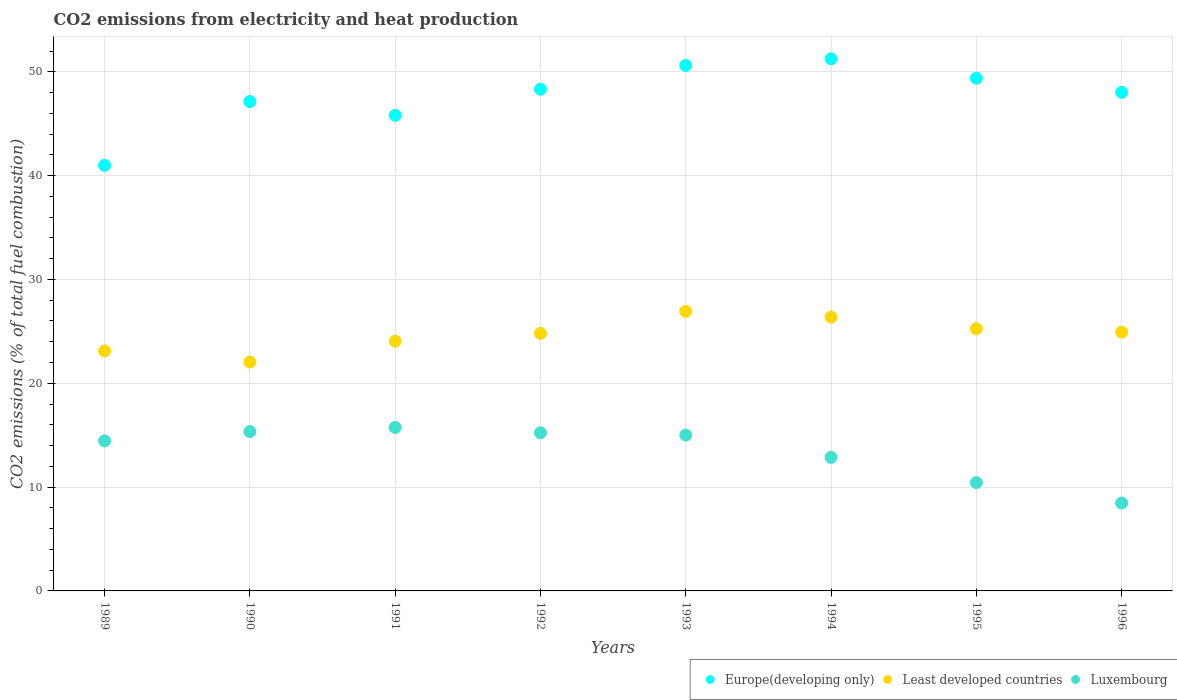What is the amount of CO2 emitted in Least developed countries in 1991?
Your answer should be very brief. 24.05. Across all years, what is the maximum amount of CO2 emitted in Luxembourg?
Provide a short and direct response. 15.75. Across all years, what is the minimum amount of CO2 emitted in Least developed countries?
Keep it short and to the point. 22.05. In which year was the amount of CO2 emitted in Luxembourg maximum?
Offer a terse response. 1991. In which year was the amount of CO2 emitted in Least developed countries minimum?
Give a very brief answer. 1990. What is the total amount of CO2 emitted in Luxembourg in the graph?
Offer a very short reply. 107.55. What is the difference between the amount of CO2 emitted in Europe(developing only) in 1989 and that in 1991?
Your response must be concise. -4.82. What is the difference between the amount of CO2 emitted in Luxembourg in 1989 and the amount of CO2 emitted in Least developed countries in 1995?
Make the answer very short. -10.8. What is the average amount of CO2 emitted in Luxembourg per year?
Your answer should be very brief. 13.44. In the year 1995, what is the difference between the amount of CO2 emitted in Europe(developing only) and amount of CO2 emitted in Least developed countries?
Keep it short and to the point. 24.12. In how many years, is the amount of CO2 emitted in Luxembourg greater than 36 %?
Keep it short and to the point. 0. What is the ratio of the amount of CO2 emitted in Europe(developing only) in 1991 to that in 1992?
Make the answer very short. 0.95. Is the difference between the amount of CO2 emitted in Europe(developing only) in 1991 and 1993 greater than the difference between the amount of CO2 emitted in Least developed countries in 1991 and 1993?
Your response must be concise. No. What is the difference between the highest and the second highest amount of CO2 emitted in Least developed countries?
Offer a terse response. 0.56. What is the difference between the highest and the lowest amount of CO2 emitted in Least developed countries?
Your response must be concise. 4.87. In how many years, is the amount of CO2 emitted in Luxembourg greater than the average amount of CO2 emitted in Luxembourg taken over all years?
Provide a short and direct response. 5. Is the sum of the amount of CO2 emitted in Europe(developing only) in 1992 and 1994 greater than the maximum amount of CO2 emitted in Luxembourg across all years?
Make the answer very short. Yes. Is it the case that in every year, the sum of the amount of CO2 emitted in Europe(developing only) and amount of CO2 emitted in Luxembourg  is greater than the amount of CO2 emitted in Least developed countries?
Your answer should be very brief. Yes. Does the amount of CO2 emitted in Least developed countries monotonically increase over the years?
Ensure brevity in your answer.  No. Is the amount of CO2 emitted in Least developed countries strictly greater than the amount of CO2 emitted in Luxembourg over the years?
Ensure brevity in your answer.  Yes. Is the amount of CO2 emitted in Least developed countries strictly less than the amount of CO2 emitted in Luxembourg over the years?
Make the answer very short. No. How many dotlines are there?
Provide a short and direct response. 3. How many years are there in the graph?
Your answer should be compact. 8. What is the difference between two consecutive major ticks on the Y-axis?
Provide a short and direct response. 10. How many legend labels are there?
Your response must be concise. 3. How are the legend labels stacked?
Keep it short and to the point. Horizontal. What is the title of the graph?
Keep it short and to the point. CO2 emissions from electricity and heat production. Does "Virgin Islands" appear as one of the legend labels in the graph?
Give a very brief answer. No. What is the label or title of the Y-axis?
Provide a short and direct response. CO2 emissions (% of total fuel combustion). What is the CO2 emissions (% of total fuel combustion) of Europe(developing only) in 1989?
Provide a short and direct response. 40.99. What is the CO2 emissions (% of total fuel combustion) of Least developed countries in 1989?
Your response must be concise. 23.12. What is the CO2 emissions (% of total fuel combustion) of Luxembourg in 1989?
Keep it short and to the point. 14.45. What is the CO2 emissions (% of total fuel combustion) of Europe(developing only) in 1990?
Your response must be concise. 47.13. What is the CO2 emissions (% of total fuel combustion) in Least developed countries in 1990?
Provide a short and direct response. 22.05. What is the CO2 emissions (% of total fuel combustion) of Luxembourg in 1990?
Provide a short and direct response. 15.35. What is the CO2 emissions (% of total fuel combustion) in Europe(developing only) in 1991?
Make the answer very short. 45.8. What is the CO2 emissions (% of total fuel combustion) of Least developed countries in 1991?
Offer a very short reply. 24.05. What is the CO2 emissions (% of total fuel combustion) in Luxembourg in 1991?
Offer a very short reply. 15.75. What is the CO2 emissions (% of total fuel combustion) in Europe(developing only) in 1992?
Offer a terse response. 48.32. What is the CO2 emissions (% of total fuel combustion) in Least developed countries in 1992?
Your answer should be compact. 24.81. What is the CO2 emissions (% of total fuel combustion) in Luxembourg in 1992?
Your answer should be compact. 15.23. What is the CO2 emissions (% of total fuel combustion) of Europe(developing only) in 1993?
Provide a short and direct response. 50.61. What is the CO2 emissions (% of total fuel combustion) of Least developed countries in 1993?
Ensure brevity in your answer.  26.92. What is the CO2 emissions (% of total fuel combustion) of Luxembourg in 1993?
Keep it short and to the point. 15.01. What is the CO2 emissions (% of total fuel combustion) of Europe(developing only) in 1994?
Offer a very short reply. 51.25. What is the CO2 emissions (% of total fuel combustion) of Least developed countries in 1994?
Your answer should be very brief. 26.37. What is the CO2 emissions (% of total fuel combustion) in Luxembourg in 1994?
Offer a terse response. 12.86. What is the CO2 emissions (% of total fuel combustion) of Europe(developing only) in 1995?
Make the answer very short. 49.38. What is the CO2 emissions (% of total fuel combustion) in Least developed countries in 1995?
Ensure brevity in your answer.  25.25. What is the CO2 emissions (% of total fuel combustion) in Luxembourg in 1995?
Your answer should be very brief. 10.43. What is the CO2 emissions (% of total fuel combustion) of Europe(developing only) in 1996?
Offer a very short reply. 48.02. What is the CO2 emissions (% of total fuel combustion) in Least developed countries in 1996?
Your answer should be very brief. 24.92. What is the CO2 emissions (% of total fuel combustion) in Luxembourg in 1996?
Offer a very short reply. 8.47. Across all years, what is the maximum CO2 emissions (% of total fuel combustion) of Europe(developing only)?
Ensure brevity in your answer.  51.25. Across all years, what is the maximum CO2 emissions (% of total fuel combustion) in Least developed countries?
Your response must be concise. 26.92. Across all years, what is the maximum CO2 emissions (% of total fuel combustion) in Luxembourg?
Your answer should be very brief. 15.75. Across all years, what is the minimum CO2 emissions (% of total fuel combustion) of Europe(developing only)?
Provide a succinct answer. 40.99. Across all years, what is the minimum CO2 emissions (% of total fuel combustion) in Least developed countries?
Your answer should be very brief. 22.05. Across all years, what is the minimum CO2 emissions (% of total fuel combustion) in Luxembourg?
Give a very brief answer. 8.47. What is the total CO2 emissions (% of total fuel combustion) in Europe(developing only) in the graph?
Provide a succinct answer. 381.5. What is the total CO2 emissions (% of total fuel combustion) in Least developed countries in the graph?
Keep it short and to the point. 197.49. What is the total CO2 emissions (% of total fuel combustion) in Luxembourg in the graph?
Provide a succinct answer. 107.55. What is the difference between the CO2 emissions (% of total fuel combustion) of Europe(developing only) in 1989 and that in 1990?
Make the answer very short. -6.14. What is the difference between the CO2 emissions (% of total fuel combustion) in Least developed countries in 1989 and that in 1990?
Make the answer very short. 1.07. What is the difference between the CO2 emissions (% of total fuel combustion) in Luxembourg in 1989 and that in 1990?
Provide a short and direct response. -0.89. What is the difference between the CO2 emissions (% of total fuel combustion) in Europe(developing only) in 1989 and that in 1991?
Offer a terse response. -4.82. What is the difference between the CO2 emissions (% of total fuel combustion) of Least developed countries in 1989 and that in 1991?
Give a very brief answer. -0.93. What is the difference between the CO2 emissions (% of total fuel combustion) of Luxembourg in 1989 and that in 1991?
Your answer should be compact. -1.29. What is the difference between the CO2 emissions (% of total fuel combustion) of Europe(developing only) in 1989 and that in 1992?
Your answer should be very brief. -7.33. What is the difference between the CO2 emissions (% of total fuel combustion) of Least developed countries in 1989 and that in 1992?
Make the answer very short. -1.69. What is the difference between the CO2 emissions (% of total fuel combustion) of Luxembourg in 1989 and that in 1992?
Your answer should be very brief. -0.78. What is the difference between the CO2 emissions (% of total fuel combustion) in Europe(developing only) in 1989 and that in 1993?
Offer a terse response. -9.62. What is the difference between the CO2 emissions (% of total fuel combustion) in Least developed countries in 1989 and that in 1993?
Offer a very short reply. -3.81. What is the difference between the CO2 emissions (% of total fuel combustion) in Luxembourg in 1989 and that in 1993?
Provide a succinct answer. -0.56. What is the difference between the CO2 emissions (% of total fuel combustion) in Europe(developing only) in 1989 and that in 1994?
Provide a succinct answer. -10.26. What is the difference between the CO2 emissions (% of total fuel combustion) of Least developed countries in 1989 and that in 1994?
Your answer should be very brief. -3.25. What is the difference between the CO2 emissions (% of total fuel combustion) of Luxembourg in 1989 and that in 1994?
Give a very brief answer. 1.59. What is the difference between the CO2 emissions (% of total fuel combustion) in Europe(developing only) in 1989 and that in 1995?
Your answer should be compact. -8.39. What is the difference between the CO2 emissions (% of total fuel combustion) of Least developed countries in 1989 and that in 1995?
Ensure brevity in your answer.  -2.14. What is the difference between the CO2 emissions (% of total fuel combustion) of Luxembourg in 1989 and that in 1995?
Offer a terse response. 4.02. What is the difference between the CO2 emissions (% of total fuel combustion) of Europe(developing only) in 1989 and that in 1996?
Keep it short and to the point. -7.03. What is the difference between the CO2 emissions (% of total fuel combustion) in Least developed countries in 1989 and that in 1996?
Keep it short and to the point. -1.81. What is the difference between the CO2 emissions (% of total fuel combustion) of Luxembourg in 1989 and that in 1996?
Your response must be concise. 5.99. What is the difference between the CO2 emissions (% of total fuel combustion) of Europe(developing only) in 1990 and that in 1991?
Make the answer very short. 1.32. What is the difference between the CO2 emissions (% of total fuel combustion) in Least developed countries in 1990 and that in 1991?
Your answer should be compact. -2. What is the difference between the CO2 emissions (% of total fuel combustion) in Luxembourg in 1990 and that in 1991?
Offer a very short reply. -0.4. What is the difference between the CO2 emissions (% of total fuel combustion) of Europe(developing only) in 1990 and that in 1992?
Your response must be concise. -1.19. What is the difference between the CO2 emissions (% of total fuel combustion) of Least developed countries in 1990 and that in 1992?
Your answer should be very brief. -2.76. What is the difference between the CO2 emissions (% of total fuel combustion) in Luxembourg in 1990 and that in 1992?
Give a very brief answer. 0.12. What is the difference between the CO2 emissions (% of total fuel combustion) in Europe(developing only) in 1990 and that in 1993?
Your response must be concise. -3.48. What is the difference between the CO2 emissions (% of total fuel combustion) of Least developed countries in 1990 and that in 1993?
Ensure brevity in your answer.  -4.87. What is the difference between the CO2 emissions (% of total fuel combustion) of Luxembourg in 1990 and that in 1993?
Your answer should be compact. 0.34. What is the difference between the CO2 emissions (% of total fuel combustion) in Europe(developing only) in 1990 and that in 1994?
Ensure brevity in your answer.  -4.12. What is the difference between the CO2 emissions (% of total fuel combustion) of Least developed countries in 1990 and that in 1994?
Give a very brief answer. -4.32. What is the difference between the CO2 emissions (% of total fuel combustion) of Luxembourg in 1990 and that in 1994?
Ensure brevity in your answer.  2.49. What is the difference between the CO2 emissions (% of total fuel combustion) in Europe(developing only) in 1990 and that in 1995?
Ensure brevity in your answer.  -2.25. What is the difference between the CO2 emissions (% of total fuel combustion) of Least developed countries in 1990 and that in 1995?
Make the answer very short. -3.2. What is the difference between the CO2 emissions (% of total fuel combustion) of Luxembourg in 1990 and that in 1995?
Your answer should be very brief. 4.91. What is the difference between the CO2 emissions (% of total fuel combustion) of Europe(developing only) in 1990 and that in 1996?
Your response must be concise. -0.89. What is the difference between the CO2 emissions (% of total fuel combustion) of Least developed countries in 1990 and that in 1996?
Offer a very short reply. -2.87. What is the difference between the CO2 emissions (% of total fuel combustion) of Luxembourg in 1990 and that in 1996?
Provide a succinct answer. 6.88. What is the difference between the CO2 emissions (% of total fuel combustion) in Europe(developing only) in 1991 and that in 1992?
Give a very brief answer. -2.52. What is the difference between the CO2 emissions (% of total fuel combustion) of Least developed countries in 1991 and that in 1992?
Make the answer very short. -0.76. What is the difference between the CO2 emissions (% of total fuel combustion) in Luxembourg in 1991 and that in 1992?
Your answer should be compact. 0.51. What is the difference between the CO2 emissions (% of total fuel combustion) of Europe(developing only) in 1991 and that in 1993?
Provide a succinct answer. -4.81. What is the difference between the CO2 emissions (% of total fuel combustion) of Least developed countries in 1991 and that in 1993?
Give a very brief answer. -2.87. What is the difference between the CO2 emissions (% of total fuel combustion) in Luxembourg in 1991 and that in 1993?
Ensure brevity in your answer.  0.74. What is the difference between the CO2 emissions (% of total fuel combustion) of Europe(developing only) in 1991 and that in 1994?
Give a very brief answer. -5.45. What is the difference between the CO2 emissions (% of total fuel combustion) of Least developed countries in 1991 and that in 1994?
Your answer should be very brief. -2.32. What is the difference between the CO2 emissions (% of total fuel combustion) of Luxembourg in 1991 and that in 1994?
Your answer should be compact. 2.88. What is the difference between the CO2 emissions (% of total fuel combustion) in Europe(developing only) in 1991 and that in 1995?
Your response must be concise. -3.57. What is the difference between the CO2 emissions (% of total fuel combustion) in Least developed countries in 1991 and that in 1995?
Your answer should be very brief. -1.2. What is the difference between the CO2 emissions (% of total fuel combustion) in Luxembourg in 1991 and that in 1995?
Offer a very short reply. 5.31. What is the difference between the CO2 emissions (% of total fuel combustion) of Europe(developing only) in 1991 and that in 1996?
Your answer should be compact. -2.21. What is the difference between the CO2 emissions (% of total fuel combustion) of Least developed countries in 1991 and that in 1996?
Give a very brief answer. -0.87. What is the difference between the CO2 emissions (% of total fuel combustion) in Luxembourg in 1991 and that in 1996?
Give a very brief answer. 7.28. What is the difference between the CO2 emissions (% of total fuel combustion) of Europe(developing only) in 1992 and that in 1993?
Give a very brief answer. -2.29. What is the difference between the CO2 emissions (% of total fuel combustion) of Least developed countries in 1992 and that in 1993?
Provide a short and direct response. -2.12. What is the difference between the CO2 emissions (% of total fuel combustion) of Luxembourg in 1992 and that in 1993?
Give a very brief answer. 0.22. What is the difference between the CO2 emissions (% of total fuel combustion) of Europe(developing only) in 1992 and that in 1994?
Your answer should be very brief. -2.93. What is the difference between the CO2 emissions (% of total fuel combustion) of Least developed countries in 1992 and that in 1994?
Provide a succinct answer. -1.56. What is the difference between the CO2 emissions (% of total fuel combustion) of Luxembourg in 1992 and that in 1994?
Ensure brevity in your answer.  2.37. What is the difference between the CO2 emissions (% of total fuel combustion) of Europe(developing only) in 1992 and that in 1995?
Provide a succinct answer. -1.06. What is the difference between the CO2 emissions (% of total fuel combustion) of Least developed countries in 1992 and that in 1995?
Offer a very short reply. -0.45. What is the difference between the CO2 emissions (% of total fuel combustion) of Luxembourg in 1992 and that in 1995?
Provide a succinct answer. 4.8. What is the difference between the CO2 emissions (% of total fuel combustion) of Europe(developing only) in 1992 and that in 1996?
Provide a short and direct response. 0.3. What is the difference between the CO2 emissions (% of total fuel combustion) of Least developed countries in 1992 and that in 1996?
Offer a terse response. -0.12. What is the difference between the CO2 emissions (% of total fuel combustion) of Luxembourg in 1992 and that in 1996?
Offer a very short reply. 6.77. What is the difference between the CO2 emissions (% of total fuel combustion) of Europe(developing only) in 1993 and that in 1994?
Keep it short and to the point. -0.64. What is the difference between the CO2 emissions (% of total fuel combustion) of Least developed countries in 1993 and that in 1994?
Offer a terse response. 0.56. What is the difference between the CO2 emissions (% of total fuel combustion) of Luxembourg in 1993 and that in 1994?
Keep it short and to the point. 2.15. What is the difference between the CO2 emissions (% of total fuel combustion) of Europe(developing only) in 1993 and that in 1995?
Your answer should be compact. 1.23. What is the difference between the CO2 emissions (% of total fuel combustion) of Least developed countries in 1993 and that in 1995?
Ensure brevity in your answer.  1.67. What is the difference between the CO2 emissions (% of total fuel combustion) of Luxembourg in 1993 and that in 1995?
Your answer should be compact. 4.57. What is the difference between the CO2 emissions (% of total fuel combustion) in Europe(developing only) in 1993 and that in 1996?
Provide a succinct answer. 2.59. What is the difference between the CO2 emissions (% of total fuel combustion) of Least developed countries in 1993 and that in 1996?
Make the answer very short. 2. What is the difference between the CO2 emissions (% of total fuel combustion) in Luxembourg in 1993 and that in 1996?
Give a very brief answer. 6.54. What is the difference between the CO2 emissions (% of total fuel combustion) of Europe(developing only) in 1994 and that in 1995?
Give a very brief answer. 1.87. What is the difference between the CO2 emissions (% of total fuel combustion) in Least developed countries in 1994 and that in 1995?
Provide a succinct answer. 1.12. What is the difference between the CO2 emissions (% of total fuel combustion) in Luxembourg in 1994 and that in 1995?
Your answer should be very brief. 2.43. What is the difference between the CO2 emissions (% of total fuel combustion) of Europe(developing only) in 1994 and that in 1996?
Provide a succinct answer. 3.23. What is the difference between the CO2 emissions (% of total fuel combustion) of Least developed countries in 1994 and that in 1996?
Offer a very short reply. 1.45. What is the difference between the CO2 emissions (% of total fuel combustion) of Luxembourg in 1994 and that in 1996?
Keep it short and to the point. 4.4. What is the difference between the CO2 emissions (% of total fuel combustion) in Europe(developing only) in 1995 and that in 1996?
Provide a short and direct response. 1.36. What is the difference between the CO2 emissions (% of total fuel combustion) of Least developed countries in 1995 and that in 1996?
Keep it short and to the point. 0.33. What is the difference between the CO2 emissions (% of total fuel combustion) of Luxembourg in 1995 and that in 1996?
Ensure brevity in your answer.  1.97. What is the difference between the CO2 emissions (% of total fuel combustion) in Europe(developing only) in 1989 and the CO2 emissions (% of total fuel combustion) in Least developed countries in 1990?
Give a very brief answer. 18.94. What is the difference between the CO2 emissions (% of total fuel combustion) in Europe(developing only) in 1989 and the CO2 emissions (% of total fuel combustion) in Luxembourg in 1990?
Provide a short and direct response. 25.64. What is the difference between the CO2 emissions (% of total fuel combustion) of Least developed countries in 1989 and the CO2 emissions (% of total fuel combustion) of Luxembourg in 1990?
Offer a terse response. 7.77. What is the difference between the CO2 emissions (% of total fuel combustion) of Europe(developing only) in 1989 and the CO2 emissions (% of total fuel combustion) of Least developed countries in 1991?
Provide a succinct answer. 16.94. What is the difference between the CO2 emissions (% of total fuel combustion) in Europe(developing only) in 1989 and the CO2 emissions (% of total fuel combustion) in Luxembourg in 1991?
Keep it short and to the point. 25.24. What is the difference between the CO2 emissions (% of total fuel combustion) of Least developed countries in 1989 and the CO2 emissions (% of total fuel combustion) of Luxembourg in 1991?
Provide a succinct answer. 7.37. What is the difference between the CO2 emissions (% of total fuel combustion) in Europe(developing only) in 1989 and the CO2 emissions (% of total fuel combustion) in Least developed countries in 1992?
Offer a very short reply. 16.18. What is the difference between the CO2 emissions (% of total fuel combustion) of Europe(developing only) in 1989 and the CO2 emissions (% of total fuel combustion) of Luxembourg in 1992?
Offer a very short reply. 25.76. What is the difference between the CO2 emissions (% of total fuel combustion) in Least developed countries in 1989 and the CO2 emissions (% of total fuel combustion) in Luxembourg in 1992?
Offer a very short reply. 7.88. What is the difference between the CO2 emissions (% of total fuel combustion) in Europe(developing only) in 1989 and the CO2 emissions (% of total fuel combustion) in Least developed countries in 1993?
Your answer should be compact. 14.06. What is the difference between the CO2 emissions (% of total fuel combustion) of Europe(developing only) in 1989 and the CO2 emissions (% of total fuel combustion) of Luxembourg in 1993?
Give a very brief answer. 25.98. What is the difference between the CO2 emissions (% of total fuel combustion) of Least developed countries in 1989 and the CO2 emissions (% of total fuel combustion) of Luxembourg in 1993?
Ensure brevity in your answer.  8.11. What is the difference between the CO2 emissions (% of total fuel combustion) in Europe(developing only) in 1989 and the CO2 emissions (% of total fuel combustion) in Least developed countries in 1994?
Your answer should be compact. 14.62. What is the difference between the CO2 emissions (% of total fuel combustion) in Europe(developing only) in 1989 and the CO2 emissions (% of total fuel combustion) in Luxembourg in 1994?
Make the answer very short. 28.13. What is the difference between the CO2 emissions (% of total fuel combustion) of Least developed countries in 1989 and the CO2 emissions (% of total fuel combustion) of Luxembourg in 1994?
Your response must be concise. 10.25. What is the difference between the CO2 emissions (% of total fuel combustion) in Europe(developing only) in 1989 and the CO2 emissions (% of total fuel combustion) in Least developed countries in 1995?
Your response must be concise. 15.73. What is the difference between the CO2 emissions (% of total fuel combustion) in Europe(developing only) in 1989 and the CO2 emissions (% of total fuel combustion) in Luxembourg in 1995?
Provide a succinct answer. 30.55. What is the difference between the CO2 emissions (% of total fuel combustion) of Least developed countries in 1989 and the CO2 emissions (% of total fuel combustion) of Luxembourg in 1995?
Your response must be concise. 12.68. What is the difference between the CO2 emissions (% of total fuel combustion) in Europe(developing only) in 1989 and the CO2 emissions (% of total fuel combustion) in Least developed countries in 1996?
Give a very brief answer. 16.06. What is the difference between the CO2 emissions (% of total fuel combustion) in Europe(developing only) in 1989 and the CO2 emissions (% of total fuel combustion) in Luxembourg in 1996?
Your response must be concise. 32.52. What is the difference between the CO2 emissions (% of total fuel combustion) in Least developed countries in 1989 and the CO2 emissions (% of total fuel combustion) in Luxembourg in 1996?
Offer a terse response. 14.65. What is the difference between the CO2 emissions (% of total fuel combustion) of Europe(developing only) in 1990 and the CO2 emissions (% of total fuel combustion) of Least developed countries in 1991?
Your answer should be compact. 23.08. What is the difference between the CO2 emissions (% of total fuel combustion) of Europe(developing only) in 1990 and the CO2 emissions (% of total fuel combustion) of Luxembourg in 1991?
Keep it short and to the point. 31.38. What is the difference between the CO2 emissions (% of total fuel combustion) in Least developed countries in 1990 and the CO2 emissions (% of total fuel combustion) in Luxembourg in 1991?
Your answer should be very brief. 6.3. What is the difference between the CO2 emissions (% of total fuel combustion) of Europe(developing only) in 1990 and the CO2 emissions (% of total fuel combustion) of Least developed countries in 1992?
Offer a very short reply. 22.32. What is the difference between the CO2 emissions (% of total fuel combustion) in Europe(developing only) in 1990 and the CO2 emissions (% of total fuel combustion) in Luxembourg in 1992?
Make the answer very short. 31.9. What is the difference between the CO2 emissions (% of total fuel combustion) in Least developed countries in 1990 and the CO2 emissions (% of total fuel combustion) in Luxembourg in 1992?
Make the answer very short. 6.82. What is the difference between the CO2 emissions (% of total fuel combustion) of Europe(developing only) in 1990 and the CO2 emissions (% of total fuel combustion) of Least developed countries in 1993?
Ensure brevity in your answer.  20.2. What is the difference between the CO2 emissions (% of total fuel combustion) in Europe(developing only) in 1990 and the CO2 emissions (% of total fuel combustion) in Luxembourg in 1993?
Your answer should be compact. 32.12. What is the difference between the CO2 emissions (% of total fuel combustion) of Least developed countries in 1990 and the CO2 emissions (% of total fuel combustion) of Luxembourg in 1993?
Your answer should be very brief. 7.04. What is the difference between the CO2 emissions (% of total fuel combustion) in Europe(developing only) in 1990 and the CO2 emissions (% of total fuel combustion) in Least developed countries in 1994?
Ensure brevity in your answer.  20.76. What is the difference between the CO2 emissions (% of total fuel combustion) in Europe(developing only) in 1990 and the CO2 emissions (% of total fuel combustion) in Luxembourg in 1994?
Your answer should be very brief. 34.27. What is the difference between the CO2 emissions (% of total fuel combustion) in Least developed countries in 1990 and the CO2 emissions (% of total fuel combustion) in Luxembourg in 1994?
Ensure brevity in your answer.  9.19. What is the difference between the CO2 emissions (% of total fuel combustion) in Europe(developing only) in 1990 and the CO2 emissions (% of total fuel combustion) in Least developed countries in 1995?
Your answer should be compact. 21.88. What is the difference between the CO2 emissions (% of total fuel combustion) in Europe(developing only) in 1990 and the CO2 emissions (% of total fuel combustion) in Luxembourg in 1995?
Make the answer very short. 36.69. What is the difference between the CO2 emissions (% of total fuel combustion) of Least developed countries in 1990 and the CO2 emissions (% of total fuel combustion) of Luxembourg in 1995?
Make the answer very short. 11.61. What is the difference between the CO2 emissions (% of total fuel combustion) of Europe(developing only) in 1990 and the CO2 emissions (% of total fuel combustion) of Least developed countries in 1996?
Provide a succinct answer. 22.2. What is the difference between the CO2 emissions (% of total fuel combustion) in Europe(developing only) in 1990 and the CO2 emissions (% of total fuel combustion) in Luxembourg in 1996?
Your response must be concise. 38.66. What is the difference between the CO2 emissions (% of total fuel combustion) in Least developed countries in 1990 and the CO2 emissions (% of total fuel combustion) in Luxembourg in 1996?
Keep it short and to the point. 13.58. What is the difference between the CO2 emissions (% of total fuel combustion) of Europe(developing only) in 1991 and the CO2 emissions (% of total fuel combustion) of Least developed countries in 1992?
Keep it short and to the point. 21. What is the difference between the CO2 emissions (% of total fuel combustion) in Europe(developing only) in 1991 and the CO2 emissions (% of total fuel combustion) in Luxembourg in 1992?
Keep it short and to the point. 30.57. What is the difference between the CO2 emissions (% of total fuel combustion) of Least developed countries in 1991 and the CO2 emissions (% of total fuel combustion) of Luxembourg in 1992?
Keep it short and to the point. 8.82. What is the difference between the CO2 emissions (% of total fuel combustion) in Europe(developing only) in 1991 and the CO2 emissions (% of total fuel combustion) in Least developed countries in 1993?
Make the answer very short. 18.88. What is the difference between the CO2 emissions (% of total fuel combustion) in Europe(developing only) in 1991 and the CO2 emissions (% of total fuel combustion) in Luxembourg in 1993?
Offer a terse response. 30.8. What is the difference between the CO2 emissions (% of total fuel combustion) of Least developed countries in 1991 and the CO2 emissions (% of total fuel combustion) of Luxembourg in 1993?
Give a very brief answer. 9.04. What is the difference between the CO2 emissions (% of total fuel combustion) of Europe(developing only) in 1991 and the CO2 emissions (% of total fuel combustion) of Least developed countries in 1994?
Keep it short and to the point. 19.44. What is the difference between the CO2 emissions (% of total fuel combustion) in Europe(developing only) in 1991 and the CO2 emissions (% of total fuel combustion) in Luxembourg in 1994?
Your answer should be compact. 32.94. What is the difference between the CO2 emissions (% of total fuel combustion) in Least developed countries in 1991 and the CO2 emissions (% of total fuel combustion) in Luxembourg in 1994?
Offer a terse response. 11.19. What is the difference between the CO2 emissions (% of total fuel combustion) of Europe(developing only) in 1991 and the CO2 emissions (% of total fuel combustion) of Least developed countries in 1995?
Offer a very short reply. 20.55. What is the difference between the CO2 emissions (% of total fuel combustion) of Europe(developing only) in 1991 and the CO2 emissions (% of total fuel combustion) of Luxembourg in 1995?
Your answer should be compact. 35.37. What is the difference between the CO2 emissions (% of total fuel combustion) of Least developed countries in 1991 and the CO2 emissions (% of total fuel combustion) of Luxembourg in 1995?
Keep it short and to the point. 13.61. What is the difference between the CO2 emissions (% of total fuel combustion) in Europe(developing only) in 1991 and the CO2 emissions (% of total fuel combustion) in Least developed countries in 1996?
Keep it short and to the point. 20.88. What is the difference between the CO2 emissions (% of total fuel combustion) in Europe(developing only) in 1991 and the CO2 emissions (% of total fuel combustion) in Luxembourg in 1996?
Provide a succinct answer. 37.34. What is the difference between the CO2 emissions (% of total fuel combustion) in Least developed countries in 1991 and the CO2 emissions (% of total fuel combustion) in Luxembourg in 1996?
Your answer should be compact. 15.58. What is the difference between the CO2 emissions (% of total fuel combustion) in Europe(developing only) in 1992 and the CO2 emissions (% of total fuel combustion) in Least developed countries in 1993?
Provide a succinct answer. 21.4. What is the difference between the CO2 emissions (% of total fuel combustion) of Europe(developing only) in 1992 and the CO2 emissions (% of total fuel combustion) of Luxembourg in 1993?
Provide a short and direct response. 33.31. What is the difference between the CO2 emissions (% of total fuel combustion) of Least developed countries in 1992 and the CO2 emissions (% of total fuel combustion) of Luxembourg in 1993?
Your answer should be very brief. 9.8. What is the difference between the CO2 emissions (% of total fuel combustion) of Europe(developing only) in 1992 and the CO2 emissions (% of total fuel combustion) of Least developed countries in 1994?
Provide a short and direct response. 21.95. What is the difference between the CO2 emissions (% of total fuel combustion) in Europe(developing only) in 1992 and the CO2 emissions (% of total fuel combustion) in Luxembourg in 1994?
Your response must be concise. 35.46. What is the difference between the CO2 emissions (% of total fuel combustion) of Least developed countries in 1992 and the CO2 emissions (% of total fuel combustion) of Luxembourg in 1994?
Make the answer very short. 11.94. What is the difference between the CO2 emissions (% of total fuel combustion) in Europe(developing only) in 1992 and the CO2 emissions (% of total fuel combustion) in Least developed countries in 1995?
Offer a terse response. 23.07. What is the difference between the CO2 emissions (% of total fuel combustion) of Europe(developing only) in 1992 and the CO2 emissions (% of total fuel combustion) of Luxembourg in 1995?
Ensure brevity in your answer.  37.89. What is the difference between the CO2 emissions (% of total fuel combustion) of Least developed countries in 1992 and the CO2 emissions (% of total fuel combustion) of Luxembourg in 1995?
Give a very brief answer. 14.37. What is the difference between the CO2 emissions (% of total fuel combustion) of Europe(developing only) in 1992 and the CO2 emissions (% of total fuel combustion) of Least developed countries in 1996?
Your response must be concise. 23.4. What is the difference between the CO2 emissions (% of total fuel combustion) of Europe(developing only) in 1992 and the CO2 emissions (% of total fuel combustion) of Luxembourg in 1996?
Make the answer very short. 39.85. What is the difference between the CO2 emissions (% of total fuel combustion) of Least developed countries in 1992 and the CO2 emissions (% of total fuel combustion) of Luxembourg in 1996?
Offer a very short reply. 16.34. What is the difference between the CO2 emissions (% of total fuel combustion) of Europe(developing only) in 1993 and the CO2 emissions (% of total fuel combustion) of Least developed countries in 1994?
Your answer should be compact. 24.24. What is the difference between the CO2 emissions (% of total fuel combustion) in Europe(developing only) in 1993 and the CO2 emissions (% of total fuel combustion) in Luxembourg in 1994?
Give a very brief answer. 37.75. What is the difference between the CO2 emissions (% of total fuel combustion) in Least developed countries in 1993 and the CO2 emissions (% of total fuel combustion) in Luxembourg in 1994?
Make the answer very short. 14.06. What is the difference between the CO2 emissions (% of total fuel combustion) in Europe(developing only) in 1993 and the CO2 emissions (% of total fuel combustion) in Least developed countries in 1995?
Provide a short and direct response. 25.36. What is the difference between the CO2 emissions (% of total fuel combustion) in Europe(developing only) in 1993 and the CO2 emissions (% of total fuel combustion) in Luxembourg in 1995?
Your response must be concise. 40.18. What is the difference between the CO2 emissions (% of total fuel combustion) in Least developed countries in 1993 and the CO2 emissions (% of total fuel combustion) in Luxembourg in 1995?
Keep it short and to the point. 16.49. What is the difference between the CO2 emissions (% of total fuel combustion) of Europe(developing only) in 1993 and the CO2 emissions (% of total fuel combustion) of Least developed countries in 1996?
Provide a succinct answer. 25.69. What is the difference between the CO2 emissions (% of total fuel combustion) in Europe(developing only) in 1993 and the CO2 emissions (% of total fuel combustion) in Luxembourg in 1996?
Make the answer very short. 42.14. What is the difference between the CO2 emissions (% of total fuel combustion) in Least developed countries in 1993 and the CO2 emissions (% of total fuel combustion) in Luxembourg in 1996?
Provide a succinct answer. 18.46. What is the difference between the CO2 emissions (% of total fuel combustion) in Europe(developing only) in 1994 and the CO2 emissions (% of total fuel combustion) in Least developed countries in 1995?
Your response must be concise. 26. What is the difference between the CO2 emissions (% of total fuel combustion) in Europe(developing only) in 1994 and the CO2 emissions (% of total fuel combustion) in Luxembourg in 1995?
Offer a very short reply. 40.82. What is the difference between the CO2 emissions (% of total fuel combustion) in Least developed countries in 1994 and the CO2 emissions (% of total fuel combustion) in Luxembourg in 1995?
Keep it short and to the point. 15.93. What is the difference between the CO2 emissions (% of total fuel combustion) in Europe(developing only) in 1994 and the CO2 emissions (% of total fuel combustion) in Least developed countries in 1996?
Offer a very short reply. 26.33. What is the difference between the CO2 emissions (% of total fuel combustion) in Europe(developing only) in 1994 and the CO2 emissions (% of total fuel combustion) in Luxembourg in 1996?
Provide a succinct answer. 42.78. What is the difference between the CO2 emissions (% of total fuel combustion) of Least developed countries in 1994 and the CO2 emissions (% of total fuel combustion) of Luxembourg in 1996?
Provide a short and direct response. 17.9. What is the difference between the CO2 emissions (% of total fuel combustion) in Europe(developing only) in 1995 and the CO2 emissions (% of total fuel combustion) in Least developed countries in 1996?
Give a very brief answer. 24.45. What is the difference between the CO2 emissions (% of total fuel combustion) in Europe(developing only) in 1995 and the CO2 emissions (% of total fuel combustion) in Luxembourg in 1996?
Provide a succinct answer. 40.91. What is the difference between the CO2 emissions (% of total fuel combustion) of Least developed countries in 1995 and the CO2 emissions (% of total fuel combustion) of Luxembourg in 1996?
Give a very brief answer. 16.79. What is the average CO2 emissions (% of total fuel combustion) of Europe(developing only) per year?
Give a very brief answer. 47.69. What is the average CO2 emissions (% of total fuel combustion) in Least developed countries per year?
Your response must be concise. 24.69. What is the average CO2 emissions (% of total fuel combustion) in Luxembourg per year?
Offer a terse response. 13.44. In the year 1989, what is the difference between the CO2 emissions (% of total fuel combustion) of Europe(developing only) and CO2 emissions (% of total fuel combustion) of Least developed countries?
Your response must be concise. 17.87. In the year 1989, what is the difference between the CO2 emissions (% of total fuel combustion) of Europe(developing only) and CO2 emissions (% of total fuel combustion) of Luxembourg?
Offer a very short reply. 26.53. In the year 1989, what is the difference between the CO2 emissions (% of total fuel combustion) of Least developed countries and CO2 emissions (% of total fuel combustion) of Luxembourg?
Ensure brevity in your answer.  8.66. In the year 1990, what is the difference between the CO2 emissions (% of total fuel combustion) in Europe(developing only) and CO2 emissions (% of total fuel combustion) in Least developed countries?
Give a very brief answer. 25.08. In the year 1990, what is the difference between the CO2 emissions (% of total fuel combustion) of Europe(developing only) and CO2 emissions (% of total fuel combustion) of Luxembourg?
Your response must be concise. 31.78. In the year 1990, what is the difference between the CO2 emissions (% of total fuel combustion) of Least developed countries and CO2 emissions (% of total fuel combustion) of Luxembourg?
Keep it short and to the point. 6.7. In the year 1991, what is the difference between the CO2 emissions (% of total fuel combustion) in Europe(developing only) and CO2 emissions (% of total fuel combustion) in Least developed countries?
Provide a short and direct response. 21.76. In the year 1991, what is the difference between the CO2 emissions (% of total fuel combustion) in Europe(developing only) and CO2 emissions (% of total fuel combustion) in Luxembourg?
Provide a short and direct response. 30.06. In the year 1991, what is the difference between the CO2 emissions (% of total fuel combustion) in Least developed countries and CO2 emissions (% of total fuel combustion) in Luxembourg?
Provide a succinct answer. 8.3. In the year 1992, what is the difference between the CO2 emissions (% of total fuel combustion) of Europe(developing only) and CO2 emissions (% of total fuel combustion) of Least developed countries?
Offer a very short reply. 23.51. In the year 1992, what is the difference between the CO2 emissions (% of total fuel combustion) of Europe(developing only) and CO2 emissions (% of total fuel combustion) of Luxembourg?
Keep it short and to the point. 33.09. In the year 1992, what is the difference between the CO2 emissions (% of total fuel combustion) of Least developed countries and CO2 emissions (% of total fuel combustion) of Luxembourg?
Provide a succinct answer. 9.57. In the year 1993, what is the difference between the CO2 emissions (% of total fuel combustion) of Europe(developing only) and CO2 emissions (% of total fuel combustion) of Least developed countries?
Make the answer very short. 23.69. In the year 1993, what is the difference between the CO2 emissions (% of total fuel combustion) in Europe(developing only) and CO2 emissions (% of total fuel combustion) in Luxembourg?
Keep it short and to the point. 35.6. In the year 1993, what is the difference between the CO2 emissions (% of total fuel combustion) in Least developed countries and CO2 emissions (% of total fuel combustion) in Luxembourg?
Offer a very short reply. 11.91. In the year 1994, what is the difference between the CO2 emissions (% of total fuel combustion) of Europe(developing only) and CO2 emissions (% of total fuel combustion) of Least developed countries?
Your response must be concise. 24.88. In the year 1994, what is the difference between the CO2 emissions (% of total fuel combustion) in Europe(developing only) and CO2 emissions (% of total fuel combustion) in Luxembourg?
Provide a succinct answer. 38.39. In the year 1994, what is the difference between the CO2 emissions (% of total fuel combustion) of Least developed countries and CO2 emissions (% of total fuel combustion) of Luxembourg?
Make the answer very short. 13.51. In the year 1995, what is the difference between the CO2 emissions (% of total fuel combustion) in Europe(developing only) and CO2 emissions (% of total fuel combustion) in Least developed countries?
Keep it short and to the point. 24.12. In the year 1995, what is the difference between the CO2 emissions (% of total fuel combustion) in Europe(developing only) and CO2 emissions (% of total fuel combustion) in Luxembourg?
Offer a very short reply. 38.94. In the year 1995, what is the difference between the CO2 emissions (% of total fuel combustion) of Least developed countries and CO2 emissions (% of total fuel combustion) of Luxembourg?
Your response must be concise. 14.82. In the year 1996, what is the difference between the CO2 emissions (% of total fuel combustion) in Europe(developing only) and CO2 emissions (% of total fuel combustion) in Least developed countries?
Ensure brevity in your answer.  23.1. In the year 1996, what is the difference between the CO2 emissions (% of total fuel combustion) in Europe(developing only) and CO2 emissions (% of total fuel combustion) in Luxembourg?
Provide a short and direct response. 39.55. In the year 1996, what is the difference between the CO2 emissions (% of total fuel combustion) in Least developed countries and CO2 emissions (% of total fuel combustion) in Luxembourg?
Your answer should be very brief. 16.46. What is the ratio of the CO2 emissions (% of total fuel combustion) of Europe(developing only) in 1989 to that in 1990?
Your answer should be compact. 0.87. What is the ratio of the CO2 emissions (% of total fuel combustion) in Least developed countries in 1989 to that in 1990?
Ensure brevity in your answer.  1.05. What is the ratio of the CO2 emissions (% of total fuel combustion) of Luxembourg in 1989 to that in 1990?
Keep it short and to the point. 0.94. What is the ratio of the CO2 emissions (% of total fuel combustion) in Europe(developing only) in 1989 to that in 1991?
Provide a short and direct response. 0.89. What is the ratio of the CO2 emissions (% of total fuel combustion) of Least developed countries in 1989 to that in 1991?
Your response must be concise. 0.96. What is the ratio of the CO2 emissions (% of total fuel combustion) of Luxembourg in 1989 to that in 1991?
Your answer should be compact. 0.92. What is the ratio of the CO2 emissions (% of total fuel combustion) in Europe(developing only) in 1989 to that in 1992?
Ensure brevity in your answer.  0.85. What is the ratio of the CO2 emissions (% of total fuel combustion) of Least developed countries in 1989 to that in 1992?
Make the answer very short. 0.93. What is the ratio of the CO2 emissions (% of total fuel combustion) in Luxembourg in 1989 to that in 1992?
Your response must be concise. 0.95. What is the ratio of the CO2 emissions (% of total fuel combustion) of Europe(developing only) in 1989 to that in 1993?
Make the answer very short. 0.81. What is the ratio of the CO2 emissions (% of total fuel combustion) of Least developed countries in 1989 to that in 1993?
Provide a succinct answer. 0.86. What is the ratio of the CO2 emissions (% of total fuel combustion) of Luxembourg in 1989 to that in 1993?
Keep it short and to the point. 0.96. What is the ratio of the CO2 emissions (% of total fuel combustion) of Europe(developing only) in 1989 to that in 1994?
Provide a short and direct response. 0.8. What is the ratio of the CO2 emissions (% of total fuel combustion) in Least developed countries in 1989 to that in 1994?
Keep it short and to the point. 0.88. What is the ratio of the CO2 emissions (% of total fuel combustion) in Luxembourg in 1989 to that in 1994?
Give a very brief answer. 1.12. What is the ratio of the CO2 emissions (% of total fuel combustion) in Europe(developing only) in 1989 to that in 1995?
Offer a very short reply. 0.83. What is the ratio of the CO2 emissions (% of total fuel combustion) in Least developed countries in 1989 to that in 1995?
Keep it short and to the point. 0.92. What is the ratio of the CO2 emissions (% of total fuel combustion) in Luxembourg in 1989 to that in 1995?
Keep it short and to the point. 1.39. What is the ratio of the CO2 emissions (% of total fuel combustion) of Europe(developing only) in 1989 to that in 1996?
Provide a succinct answer. 0.85. What is the ratio of the CO2 emissions (% of total fuel combustion) of Least developed countries in 1989 to that in 1996?
Your response must be concise. 0.93. What is the ratio of the CO2 emissions (% of total fuel combustion) of Luxembourg in 1989 to that in 1996?
Your answer should be very brief. 1.71. What is the ratio of the CO2 emissions (% of total fuel combustion) of Europe(developing only) in 1990 to that in 1991?
Make the answer very short. 1.03. What is the ratio of the CO2 emissions (% of total fuel combustion) in Least developed countries in 1990 to that in 1991?
Make the answer very short. 0.92. What is the ratio of the CO2 emissions (% of total fuel combustion) of Luxembourg in 1990 to that in 1991?
Provide a short and direct response. 0.97. What is the ratio of the CO2 emissions (% of total fuel combustion) in Europe(developing only) in 1990 to that in 1992?
Ensure brevity in your answer.  0.98. What is the ratio of the CO2 emissions (% of total fuel combustion) of Least developed countries in 1990 to that in 1992?
Make the answer very short. 0.89. What is the ratio of the CO2 emissions (% of total fuel combustion) in Luxembourg in 1990 to that in 1992?
Provide a short and direct response. 1.01. What is the ratio of the CO2 emissions (% of total fuel combustion) of Europe(developing only) in 1990 to that in 1993?
Keep it short and to the point. 0.93. What is the ratio of the CO2 emissions (% of total fuel combustion) in Least developed countries in 1990 to that in 1993?
Provide a short and direct response. 0.82. What is the ratio of the CO2 emissions (% of total fuel combustion) in Luxembourg in 1990 to that in 1993?
Offer a terse response. 1.02. What is the ratio of the CO2 emissions (% of total fuel combustion) in Europe(developing only) in 1990 to that in 1994?
Give a very brief answer. 0.92. What is the ratio of the CO2 emissions (% of total fuel combustion) in Least developed countries in 1990 to that in 1994?
Offer a very short reply. 0.84. What is the ratio of the CO2 emissions (% of total fuel combustion) of Luxembourg in 1990 to that in 1994?
Your response must be concise. 1.19. What is the ratio of the CO2 emissions (% of total fuel combustion) of Europe(developing only) in 1990 to that in 1995?
Offer a terse response. 0.95. What is the ratio of the CO2 emissions (% of total fuel combustion) in Least developed countries in 1990 to that in 1995?
Give a very brief answer. 0.87. What is the ratio of the CO2 emissions (% of total fuel combustion) in Luxembourg in 1990 to that in 1995?
Your response must be concise. 1.47. What is the ratio of the CO2 emissions (% of total fuel combustion) of Europe(developing only) in 1990 to that in 1996?
Give a very brief answer. 0.98. What is the ratio of the CO2 emissions (% of total fuel combustion) of Least developed countries in 1990 to that in 1996?
Your answer should be compact. 0.88. What is the ratio of the CO2 emissions (% of total fuel combustion) of Luxembourg in 1990 to that in 1996?
Offer a terse response. 1.81. What is the ratio of the CO2 emissions (% of total fuel combustion) in Europe(developing only) in 1991 to that in 1992?
Your response must be concise. 0.95. What is the ratio of the CO2 emissions (% of total fuel combustion) of Least developed countries in 1991 to that in 1992?
Give a very brief answer. 0.97. What is the ratio of the CO2 emissions (% of total fuel combustion) in Luxembourg in 1991 to that in 1992?
Your answer should be very brief. 1.03. What is the ratio of the CO2 emissions (% of total fuel combustion) of Europe(developing only) in 1991 to that in 1993?
Provide a succinct answer. 0.91. What is the ratio of the CO2 emissions (% of total fuel combustion) of Least developed countries in 1991 to that in 1993?
Offer a terse response. 0.89. What is the ratio of the CO2 emissions (% of total fuel combustion) in Luxembourg in 1991 to that in 1993?
Provide a succinct answer. 1.05. What is the ratio of the CO2 emissions (% of total fuel combustion) in Europe(developing only) in 1991 to that in 1994?
Your answer should be compact. 0.89. What is the ratio of the CO2 emissions (% of total fuel combustion) of Least developed countries in 1991 to that in 1994?
Keep it short and to the point. 0.91. What is the ratio of the CO2 emissions (% of total fuel combustion) of Luxembourg in 1991 to that in 1994?
Give a very brief answer. 1.22. What is the ratio of the CO2 emissions (% of total fuel combustion) of Europe(developing only) in 1991 to that in 1995?
Keep it short and to the point. 0.93. What is the ratio of the CO2 emissions (% of total fuel combustion) in Least developed countries in 1991 to that in 1995?
Your response must be concise. 0.95. What is the ratio of the CO2 emissions (% of total fuel combustion) in Luxembourg in 1991 to that in 1995?
Provide a succinct answer. 1.51. What is the ratio of the CO2 emissions (% of total fuel combustion) in Europe(developing only) in 1991 to that in 1996?
Give a very brief answer. 0.95. What is the ratio of the CO2 emissions (% of total fuel combustion) of Least developed countries in 1991 to that in 1996?
Make the answer very short. 0.96. What is the ratio of the CO2 emissions (% of total fuel combustion) of Luxembourg in 1991 to that in 1996?
Your response must be concise. 1.86. What is the ratio of the CO2 emissions (% of total fuel combustion) in Europe(developing only) in 1992 to that in 1993?
Your answer should be very brief. 0.95. What is the ratio of the CO2 emissions (% of total fuel combustion) in Least developed countries in 1992 to that in 1993?
Give a very brief answer. 0.92. What is the ratio of the CO2 emissions (% of total fuel combustion) in Luxembourg in 1992 to that in 1993?
Offer a terse response. 1.01. What is the ratio of the CO2 emissions (% of total fuel combustion) in Europe(developing only) in 1992 to that in 1994?
Your answer should be compact. 0.94. What is the ratio of the CO2 emissions (% of total fuel combustion) in Least developed countries in 1992 to that in 1994?
Provide a succinct answer. 0.94. What is the ratio of the CO2 emissions (% of total fuel combustion) in Luxembourg in 1992 to that in 1994?
Offer a very short reply. 1.18. What is the ratio of the CO2 emissions (% of total fuel combustion) of Europe(developing only) in 1992 to that in 1995?
Provide a succinct answer. 0.98. What is the ratio of the CO2 emissions (% of total fuel combustion) of Least developed countries in 1992 to that in 1995?
Give a very brief answer. 0.98. What is the ratio of the CO2 emissions (% of total fuel combustion) of Luxembourg in 1992 to that in 1995?
Provide a short and direct response. 1.46. What is the ratio of the CO2 emissions (% of total fuel combustion) in Europe(developing only) in 1992 to that in 1996?
Your answer should be compact. 1.01. What is the ratio of the CO2 emissions (% of total fuel combustion) of Luxembourg in 1992 to that in 1996?
Your answer should be compact. 1.8. What is the ratio of the CO2 emissions (% of total fuel combustion) of Europe(developing only) in 1993 to that in 1994?
Offer a terse response. 0.99. What is the ratio of the CO2 emissions (% of total fuel combustion) in Least developed countries in 1993 to that in 1994?
Provide a succinct answer. 1.02. What is the ratio of the CO2 emissions (% of total fuel combustion) in Luxembourg in 1993 to that in 1994?
Ensure brevity in your answer.  1.17. What is the ratio of the CO2 emissions (% of total fuel combustion) of Least developed countries in 1993 to that in 1995?
Make the answer very short. 1.07. What is the ratio of the CO2 emissions (% of total fuel combustion) of Luxembourg in 1993 to that in 1995?
Keep it short and to the point. 1.44. What is the ratio of the CO2 emissions (% of total fuel combustion) of Europe(developing only) in 1993 to that in 1996?
Provide a succinct answer. 1.05. What is the ratio of the CO2 emissions (% of total fuel combustion) of Least developed countries in 1993 to that in 1996?
Provide a succinct answer. 1.08. What is the ratio of the CO2 emissions (% of total fuel combustion) in Luxembourg in 1993 to that in 1996?
Keep it short and to the point. 1.77. What is the ratio of the CO2 emissions (% of total fuel combustion) of Europe(developing only) in 1994 to that in 1995?
Keep it short and to the point. 1.04. What is the ratio of the CO2 emissions (% of total fuel combustion) in Least developed countries in 1994 to that in 1995?
Ensure brevity in your answer.  1.04. What is the ratio of the CO2 emissions (% of total fuel combustion) of Luxembourg in 1994 to that in 1995?
Give a very brief answer. 1.23. What is the ratio of the CO2 emissions (% of total fuel combustion) of Europe(developing only) in 1994 to that in 1996?
Ensure brevity in your answer.  1.07. What is the ratio of the CO2 emissions (% of total fuel combustion) in Least developed countries in 1994 to that in 1996?
Give a very brief answer. 1.06. What is the ratio of the CO2 emissions (% of total fuel combustion) of Luxembourg in 1994 to that in 1996?
Keep it short and to the point. 1.52. What is the ratio of the CO2 emissions (% of total fuel combustion) of Europe(developing only) in 1995 to that in 1996?
Your response must be concise. 1.03. What is the ratio of the CO2 emissions (% of total fuel combustion) of Least developed countries in 1995 to that in 1996?
Your response must be concise. 1.01. What is the ratio of the CO2 emissions (% of total fuel combustion) of Luxembourg in 1995 to that in 1996?
Your answer should be very brief. 1.23. What is the difference between the highest and the second highest CO2 emissions (% of total fuel combustion) in Europe(developing only)?
Offer a terse response. 0.64. What is the difference between the highest and the second highest CO2 emissions (% of total fuel combustion) in Least developed countries?
Make the answer very short. 0.56. What is the difference between the highest and the second highest CO2 emissions (% of total fuel combustion) in Luxembourg?
Provide a succinct answer. 0.4. What is the difference between the highest and the lowest CO2 emissions (% of total fuel combustion) in Europe(developing only)?
Offer a terse response. 10.26. What is the difference between the highest and the lowest CO2 emissions (% of total fuel combustion) in Least developed countries?
Provide a succinct answer. 4.87. What is the difference between the highest and the lowest CO2 emissions (% of total fuel combustion) in Luxembourg?
Give a very brief answer. 7.28. 